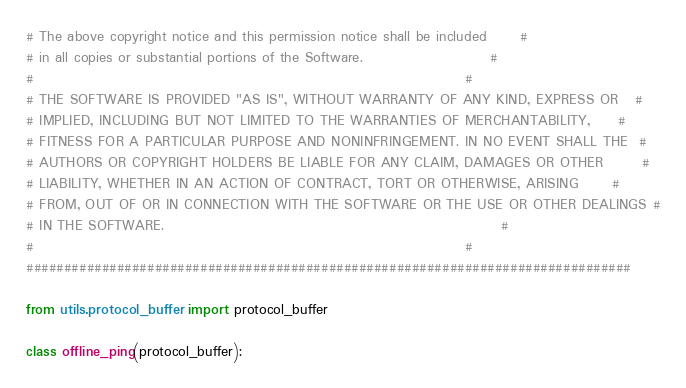<code> <loc_0><loc_0><loc_500><loc_500><_Python_># The above copyright notice and this permission notice shall be included      #
# in all copies or substantial portions of the Software.                       #
#                                                                              #
# THE SOFTWARE IS PROVIDED "AS IS", WITHOUT WARRANTY OF ANY KIND, EXPRESS OR   #
# IMPLIED, INCLUDING BUT NOT LIMITED TO THE WARRANTIES OF MERCHANTABILITY,     #
# FITNESS FOR A PARTICULAR PURPOSE AND NONINFRINGEMENT. IN NO EVENT SHALL THE  #
# AUTHORS OR COPYRIGHT HOLDERS BE LIABLE FOR ANY CLAIM, DAMAGES OR OTHER       #
# LIABILITY, WHETHER IN AN ACTION OF CONTRACT, TORT OR OTHERWISE, ARISING      #
# FROM, OUT OF OR IN CONNECTION WITH THE SOFTWARE OR THE USE OR OTHER DEALINGS #
# IN THE SOFTWARE.                                                             #
#                                                                              #
################################################################################

from utils.protocol_buffer import protocol_buffer

class offline_ping(protocol_buffer):</code> 